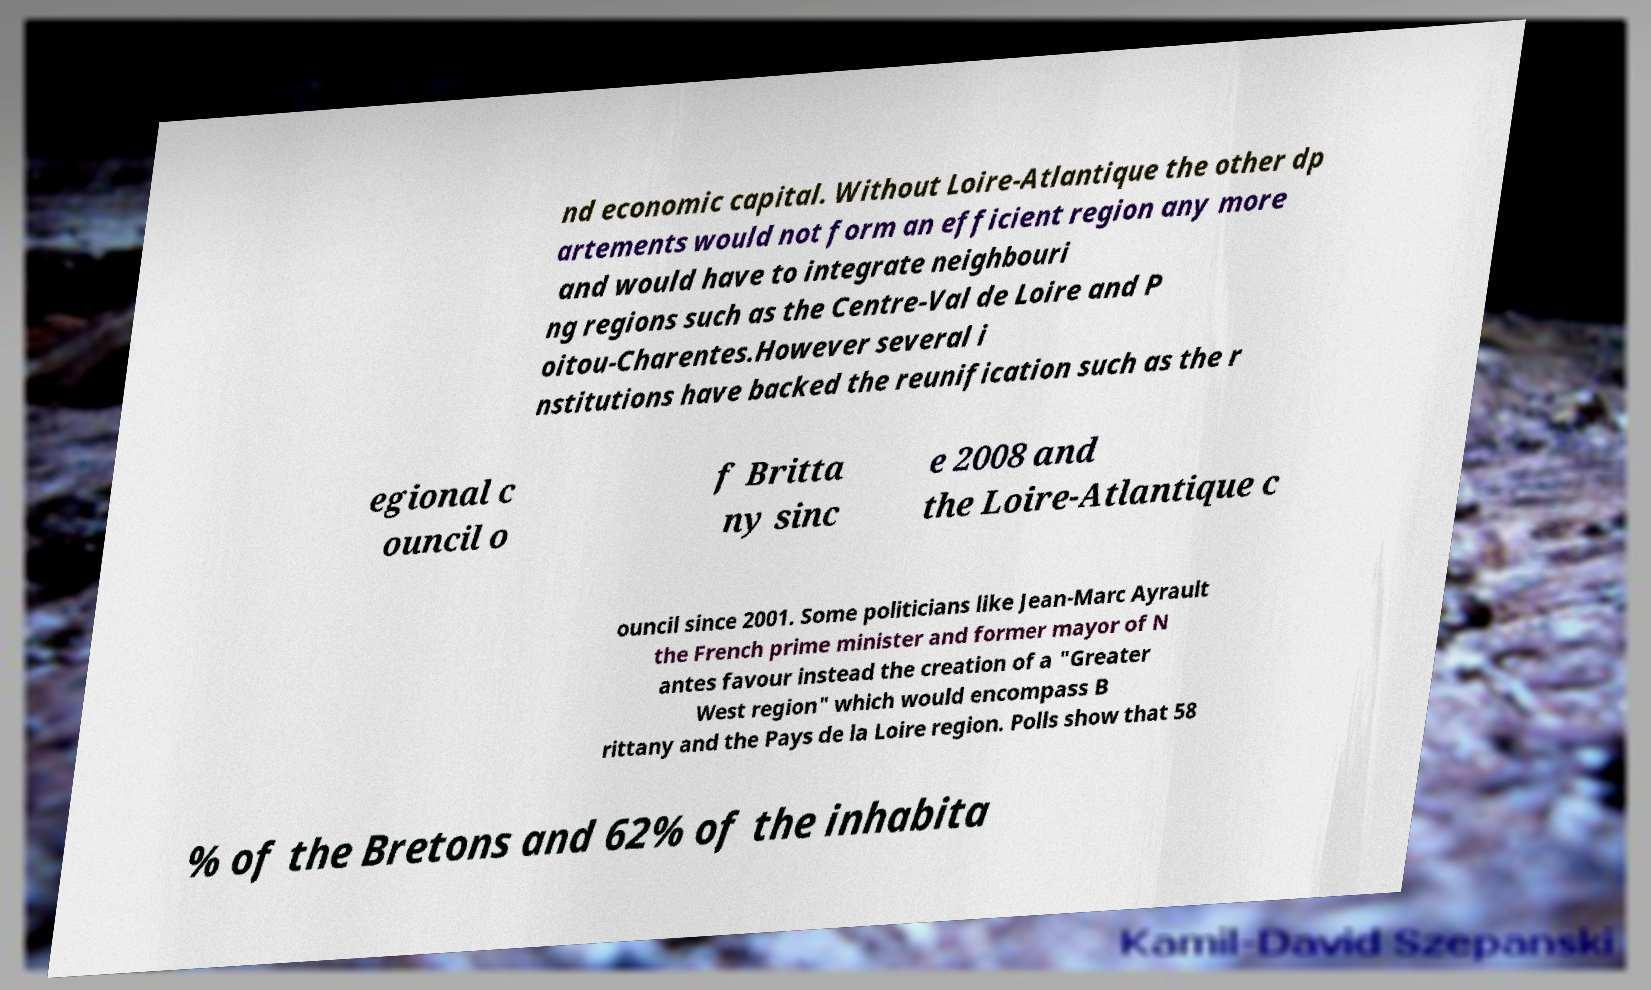What messages or text are displayed in this image? I need them in a readable, typed format. nd economic capital. Without Loire-Atlantique the other dp artements would not form an efficient region any more and would have to integrate neighbouri ng regions such as the Centre-Val de Loire and P oitou-Charentes.However several i nstitutions have backed the reunification such as the r egional c ouncil o f Britta ny sinc e 2008 and the Loire-Atlantique c ouncil since 2001. Some politicians like Jean-Marc Ayrault the French prime minister and former mayor of N antes favour instead the creation of a "Greater West region" which would encompass B rittany and the Pays de la Loire region. Polls show that 58 % of the Bretons and 62% of the inhabita 